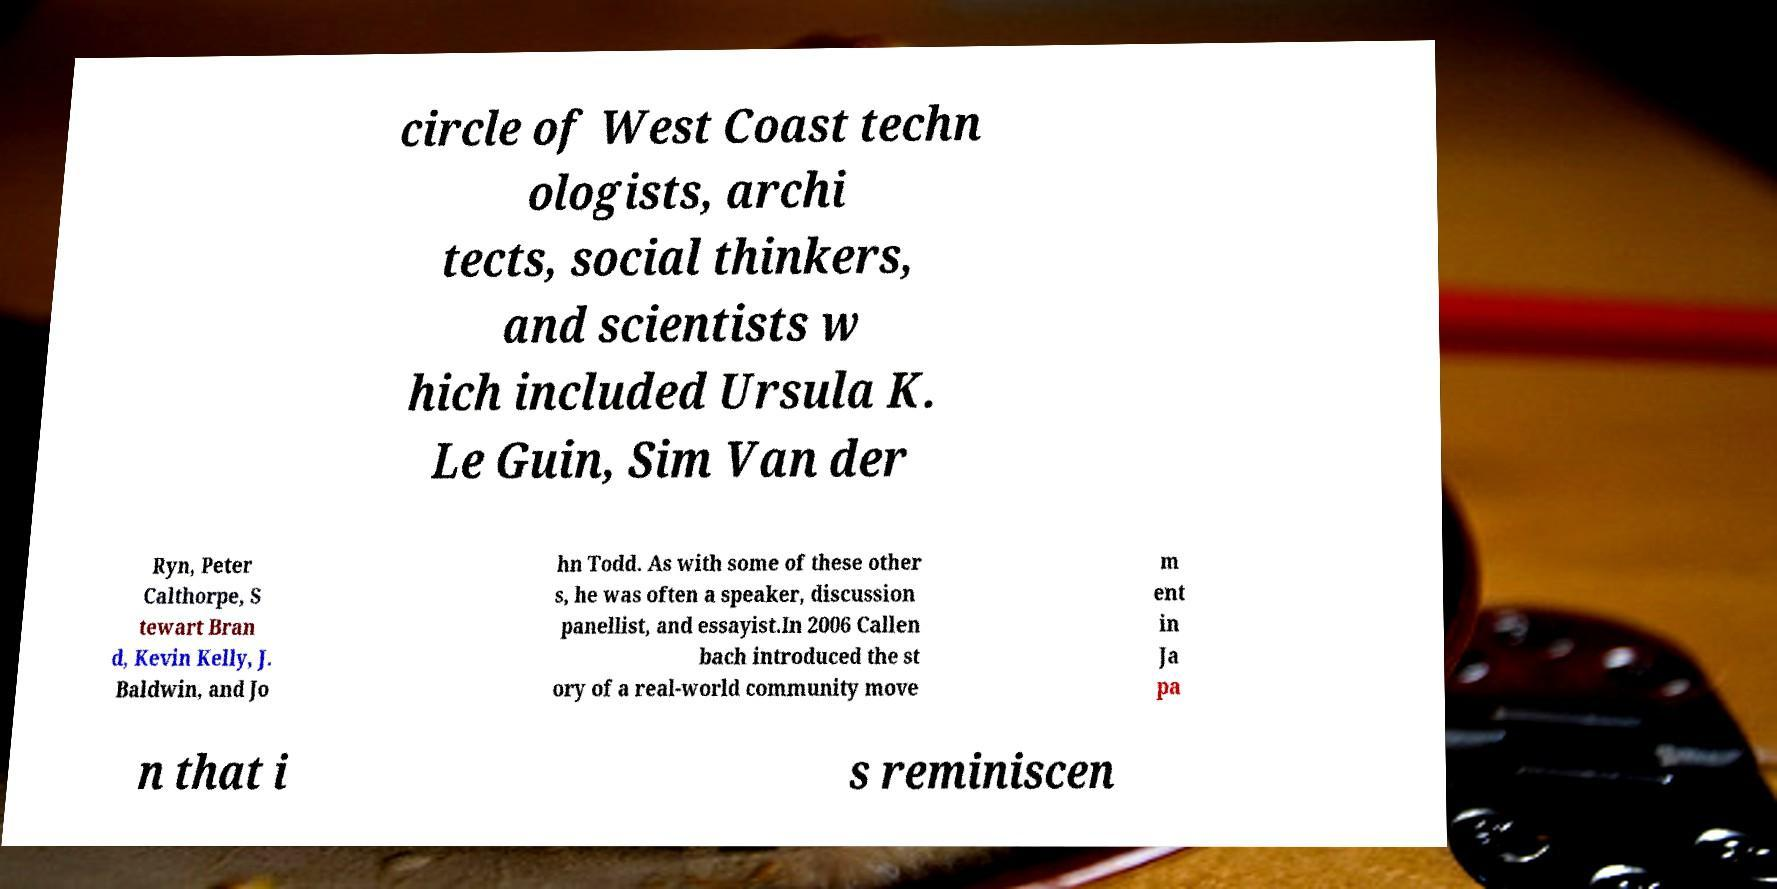Could you extract and type out the text from this image? circle of West Coast techn ologists, archi tects, social thinkers, and scientists w hich included Ursula K. Le Guin, Sim Van der Ryn, Peter Calthorpe, S tewart Bran d, Kevin Kelly, J. Baldwin, and Jo hn Todd. As with some of these other s, he was often a speaker, discussion panellist, and essayist.In 2006 Callen bach introduced the st ory of a real-world community move m ent in Ja pa n that i s reminiscen 